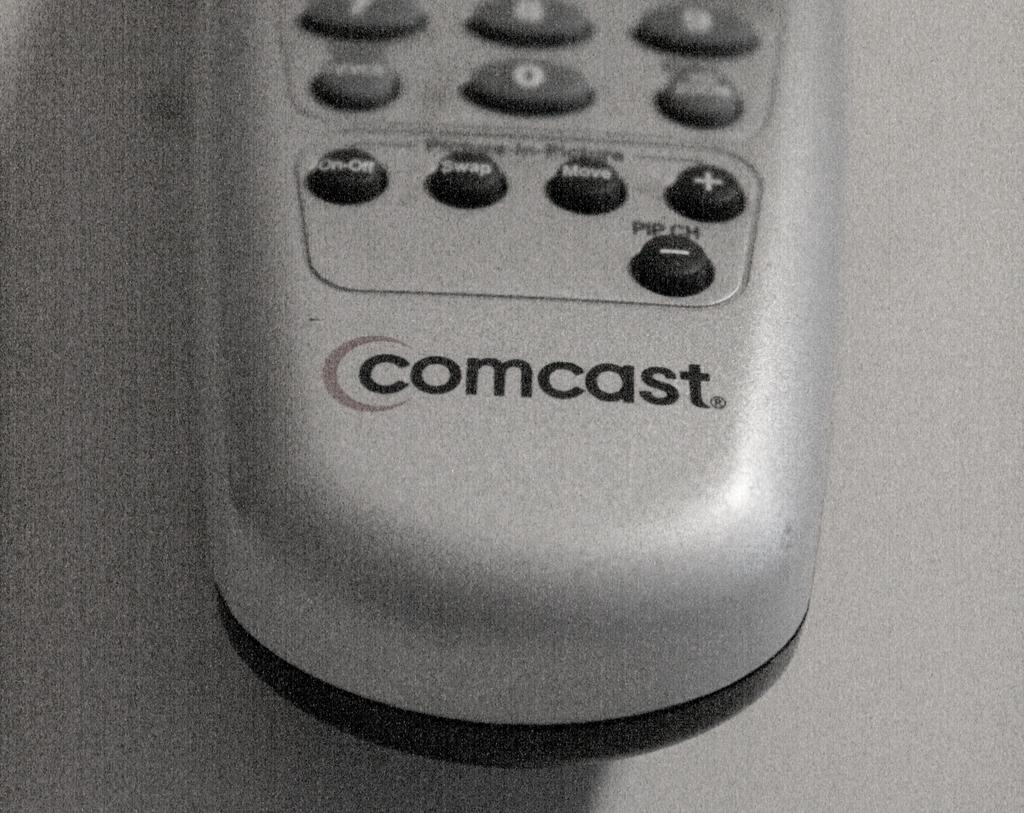<image>
Provide a brief description of the given image. The bottom of a Comcast silver remote control. 